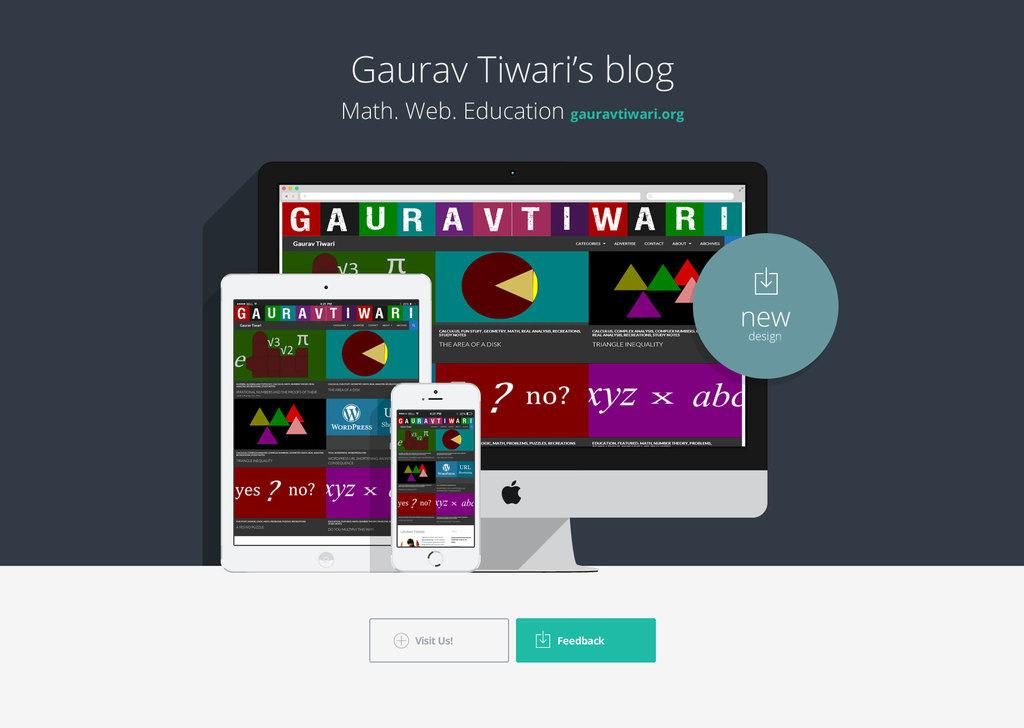<image>
Describe the image concisely. A graphic advertising Gaurav Tiwari's blog with an iphone, ipad, and apple desktop computer 